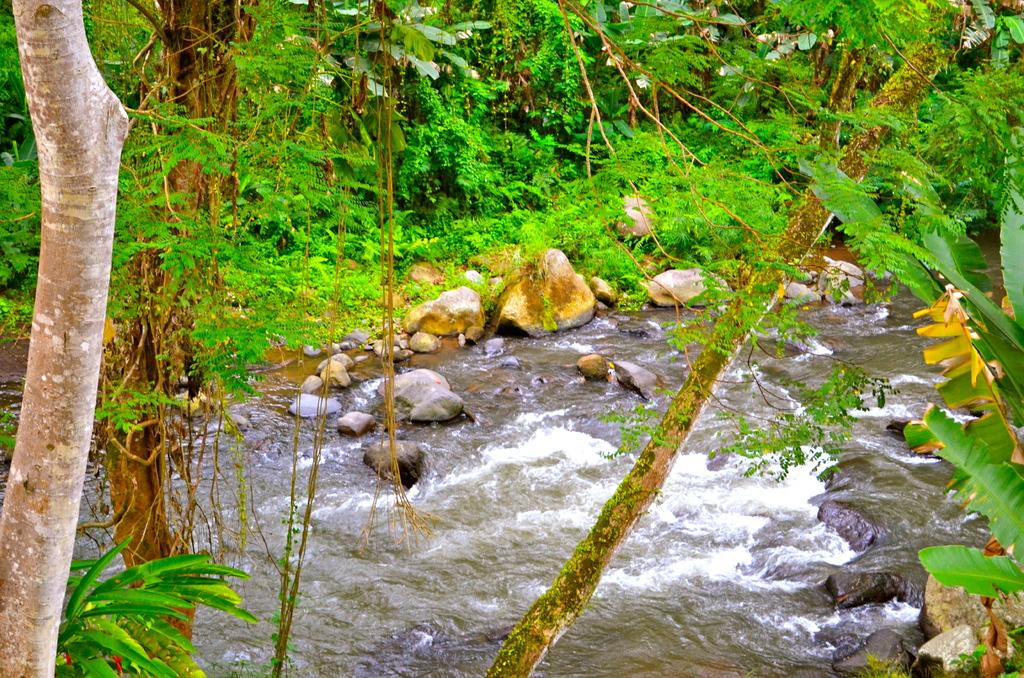What type of natural elements can be seen in the image? There are rocks, water, plants, and trees in the image. Can you describe the water in the image? The water is visible in the image, but its specific characteristics are not mentioned. What type of vegetation is present in the image? There are plants and trees in the image. Can you see an owl perched on one of the trees in the image? There is no owl present in the image; only rocks, water, plants, and trees are visible. How many ants can be seen crawling on the rocks in the image? There is no mention of ants in the image; only rocks, water, plants, and trees are visible. 